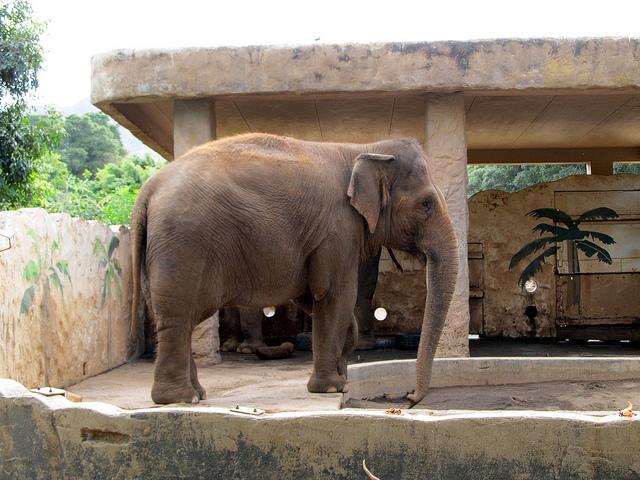How many elephants are in the scene?
Concise answer only. 1. Is this elephant in the wild?
Quick response, please. No. What is the color of the stuff on the elephant's back?
Write a very short answer. Brown. Do the palm trees in the photo need water?
Concise answer only. No. 